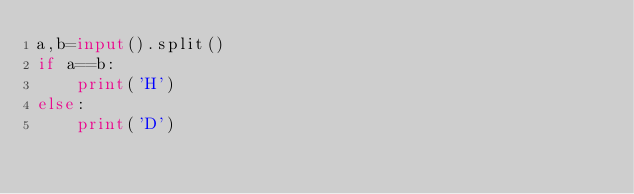Convert code to text. <code><loc_0><loc_0><loc_500><loc_500><_Python_>a,b=input().split()
if a==b:
    print('H')
else:
    print('D')</code> 